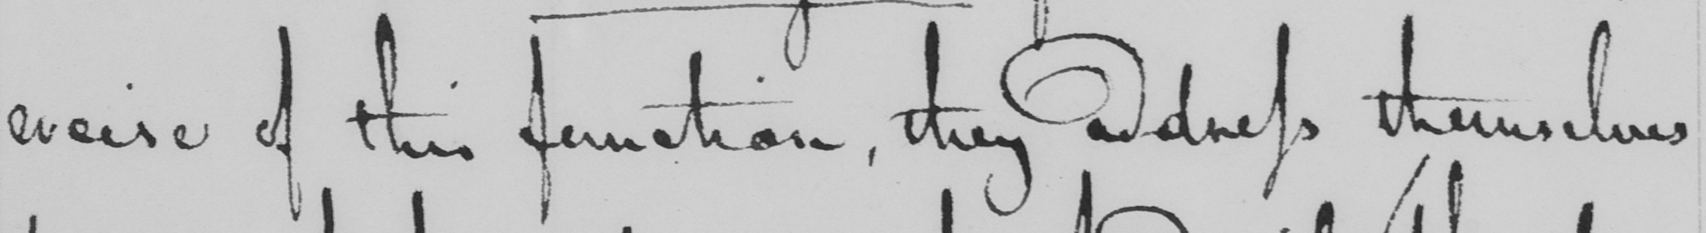Please provide the text content of this handwritten line. ercise of this function , they address themselves 